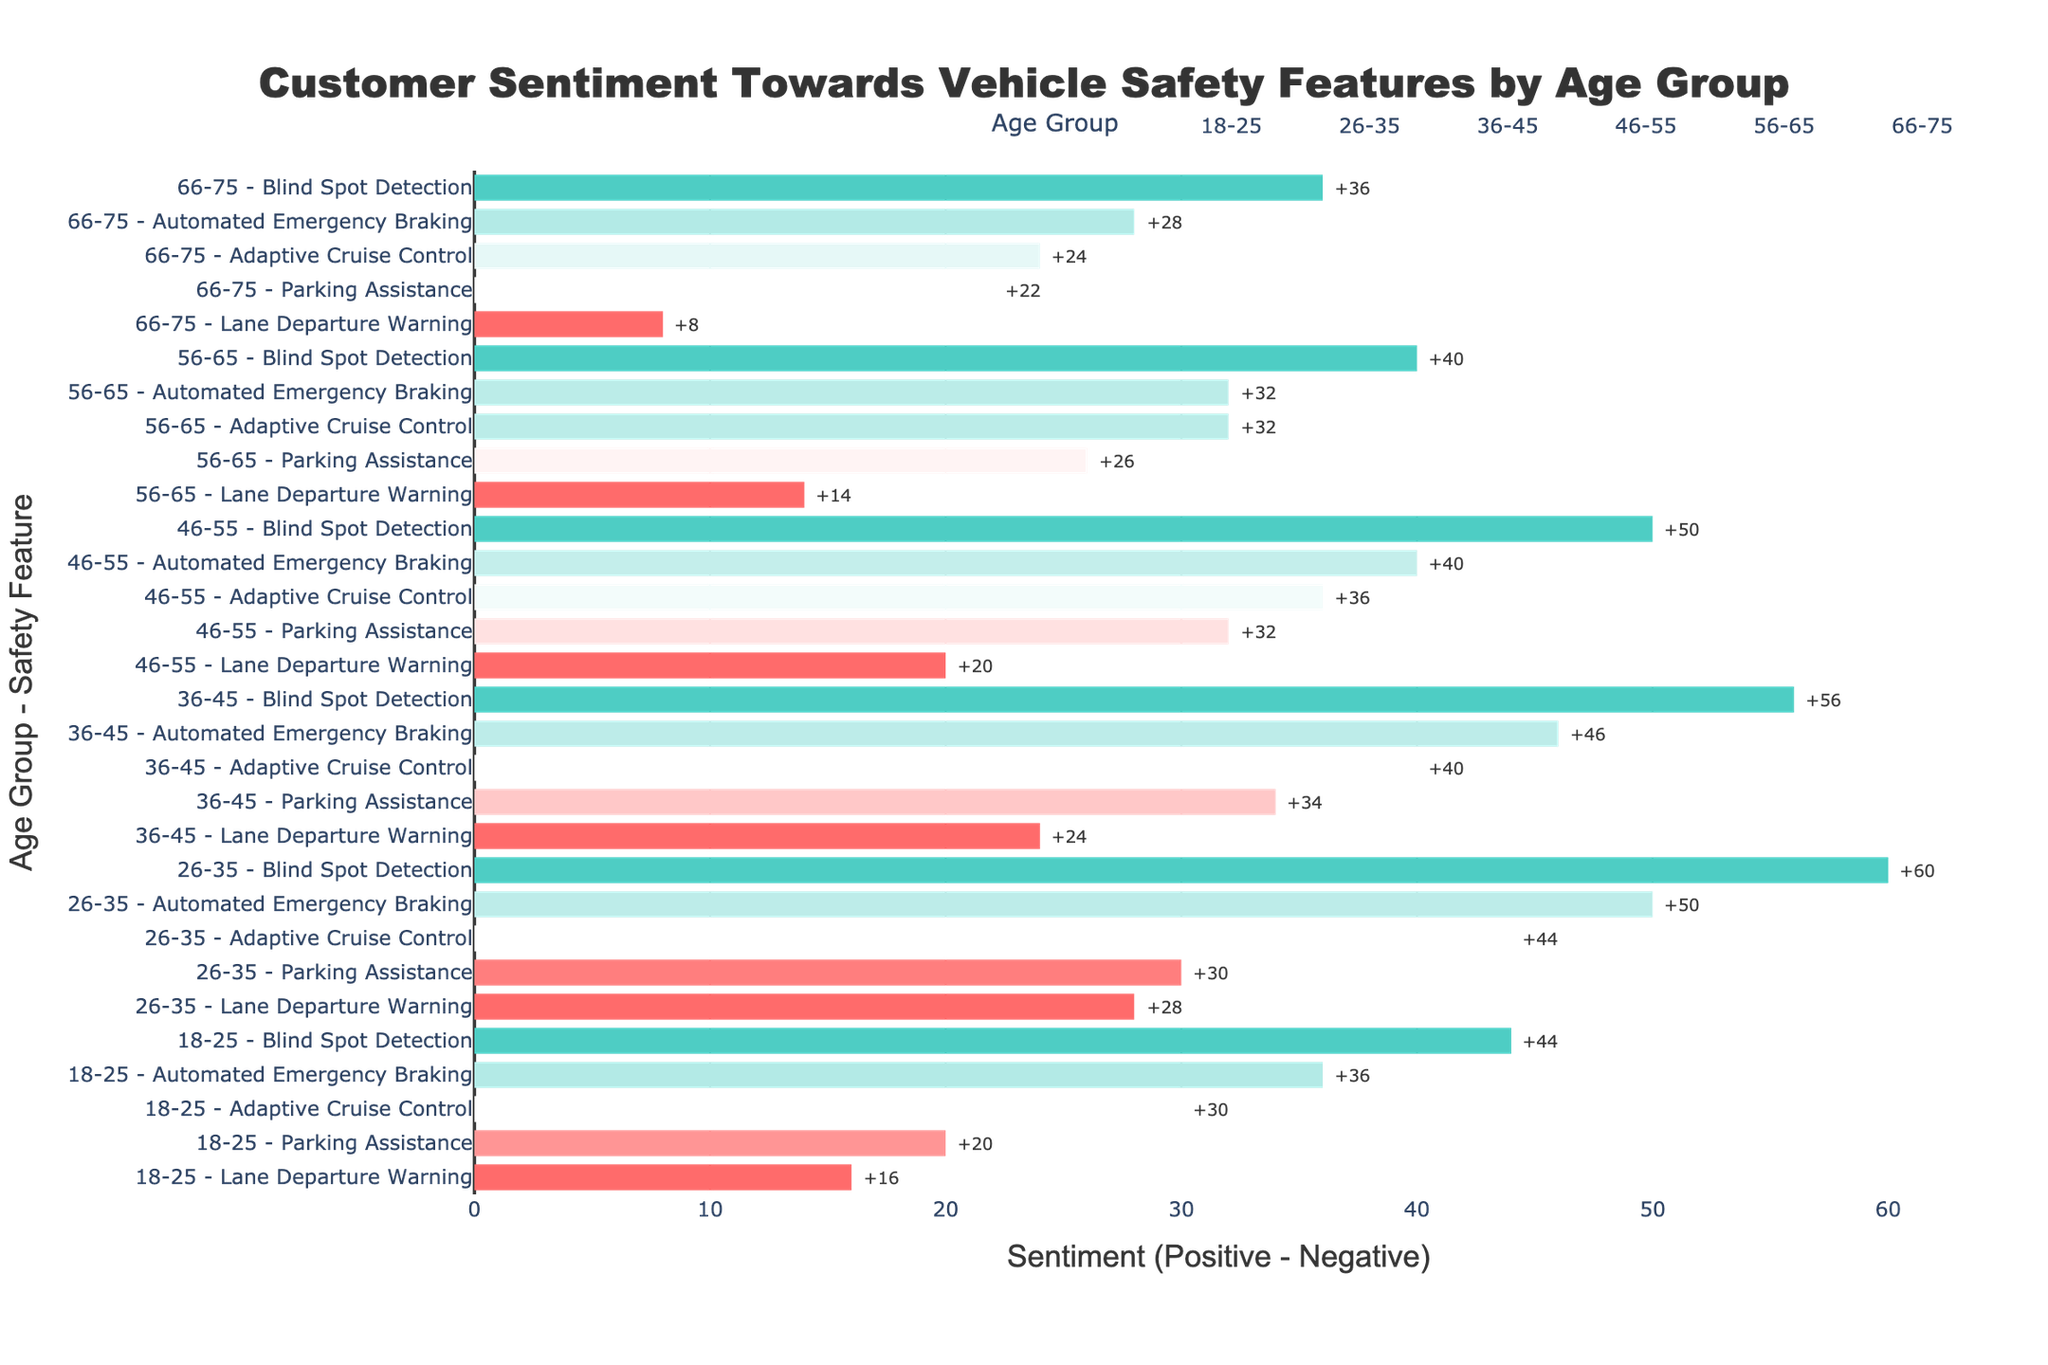Which age group has the highest positive sentiment for Blind Spot Detection? The 26-35 age group has the highest positive sentiment for Blind Spot Detection, which can be observed by comparing the lengths of the bars for this feature across different age groups.
Answer: 26-35 Which vehicle safety feature has the lowest sentiment in the 66-75 age group? By looking at the lengths of the bars within the 66-75 age group, Lane Departure Warning has the lowest sentiment value.
Answer: Lane Departure Warning Compare the sentiment towards Automated Emergency Braking between the 18-25 and 46-55 age groups. Which age group views it more positively? The positive sentiment for Automated Emergency Braking is higher in the 18-25 age group (+36) compared to the 46-55 age group (+40).
Answer: 18-25 What is the overall trend in sentiment toward Adaptive Cruise Control across all age groups? The sentiment towards Adaptive Cruise Control tends to decrease as the age group increases, which is visually noticeable by the changing bar lengths from positive to less positive.
Answer: Decreasing How does the sentiment for Lane Departure Warning differ between the 26-35 and 56-65 age groups? The sentiment for Lane Departure Warning in the 26-35 age group (+28) is significantly higher than in the 56-65 age group (+14).
Answer: 26-35 > 56-65 Which age group shows the least positive sentiment towards Parking Assistance? The 66-75 age group displays the least positive sentiment towards Parking Assistance, as it has the shortest bar compared to other age groups.
Answer: 66-75 What is the average sentiment for Blind Spot Detection across all age groups? To find the average sentiment for Blind Spot Detection across all age groups, sum all the sentiment values and then divide by the number of age groups (72 + 80 + 78 + 75 + 70 + 68), resulting in an average of 73.83.
Answer: 73.83 What's the difference in sentiment towards Lane Departure Warning between the 18-25 and 36-45 age groups? The sentiment in the 18-25 age group is +16, whereas it is +24 in the 36-45 age group. The difference is 24 - 16 = +8.
Answer: +8 